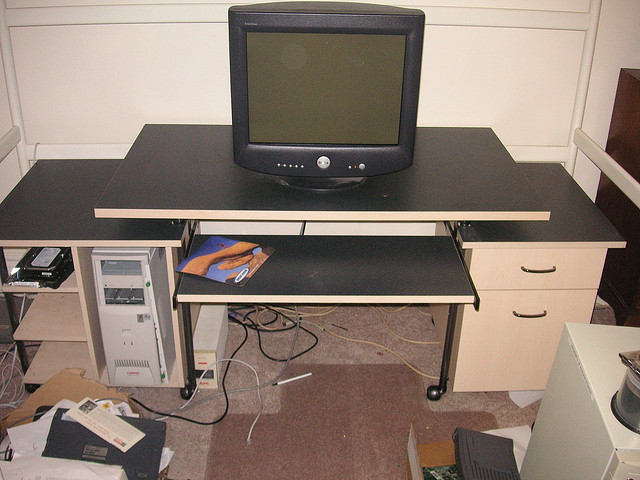Can you describe the items on the desk? On the desk, there is a large CRT monitor centrally positioned. Underneath the monitor, there appears to be a dark keyboard on a sliding tray. No other items are visible on the desk's surface. 